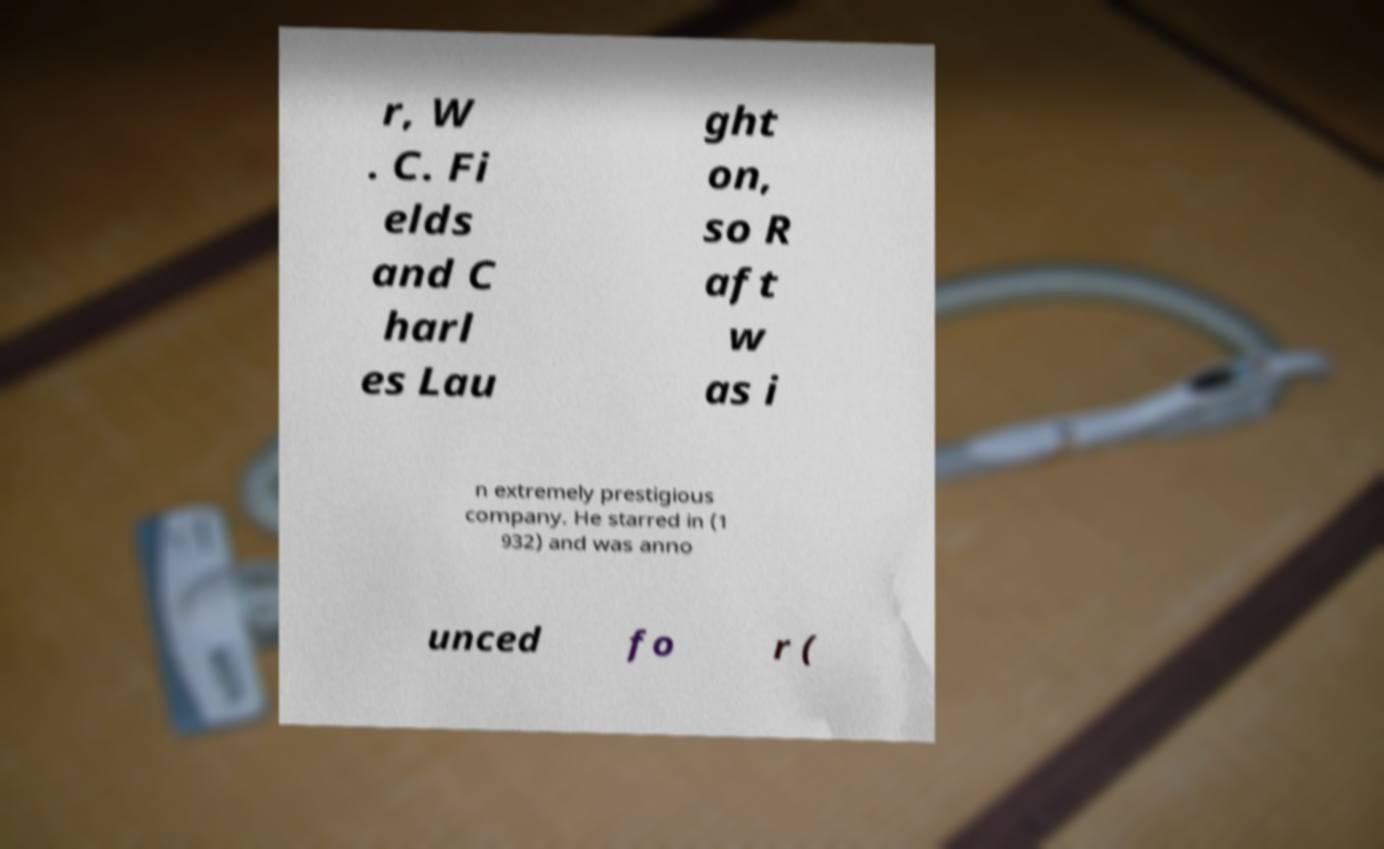For documentation purposes, I need the text within this image transcribed. Could you provide that? r, W . C. Fi elds and C harl es Lau ght on, so R aft w as i n extremely prestigious company. He starred in (1 932) and was anno unced fo r ( 